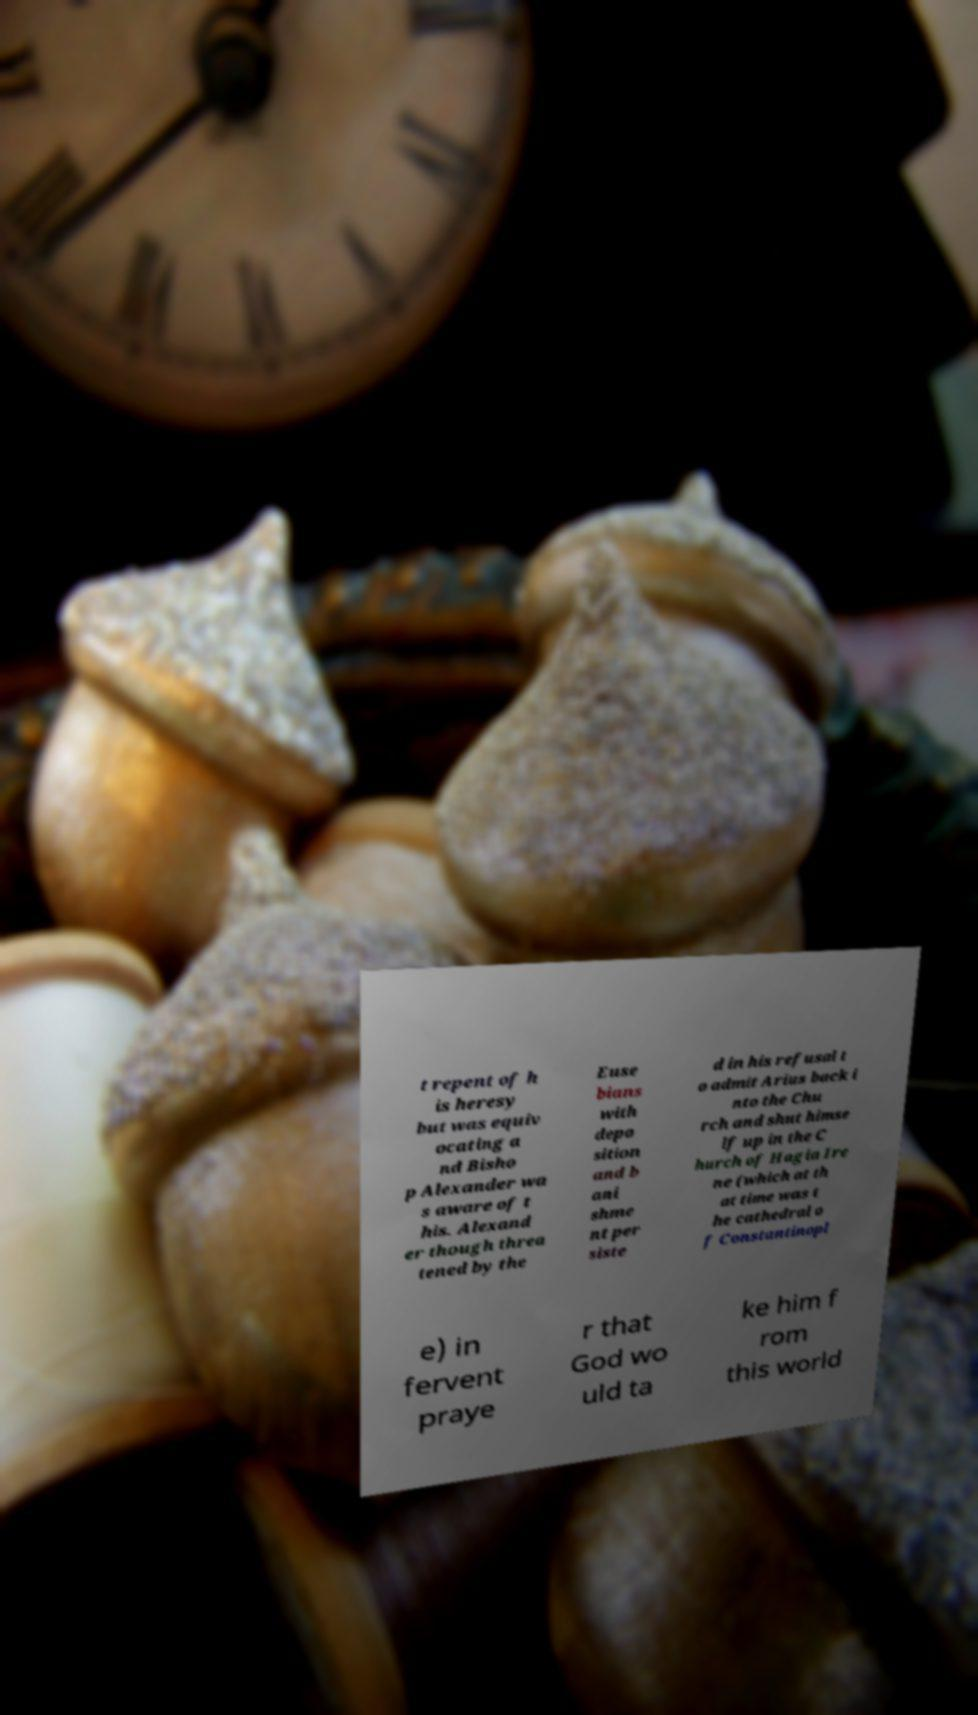Can you read and provide the text displayed in the image?This photo seems to have some interesting text. Can you extract and type it out for me? t repent of h is heresy but was equiv ocating a nd Bisho p Alexander wa s aware of t his. Alexand er though threa tened by the Euse bians with depo sition and b ani shme nt per siste d in his refusal t o admit Arius back i nto the Chu rch and shut himse lf up in the C hurch of Hagia Ire ne (which at th at time was t he cathedral o f Constantinopl e) in fervent praye r that God wo uld ta ke him f rom this world 